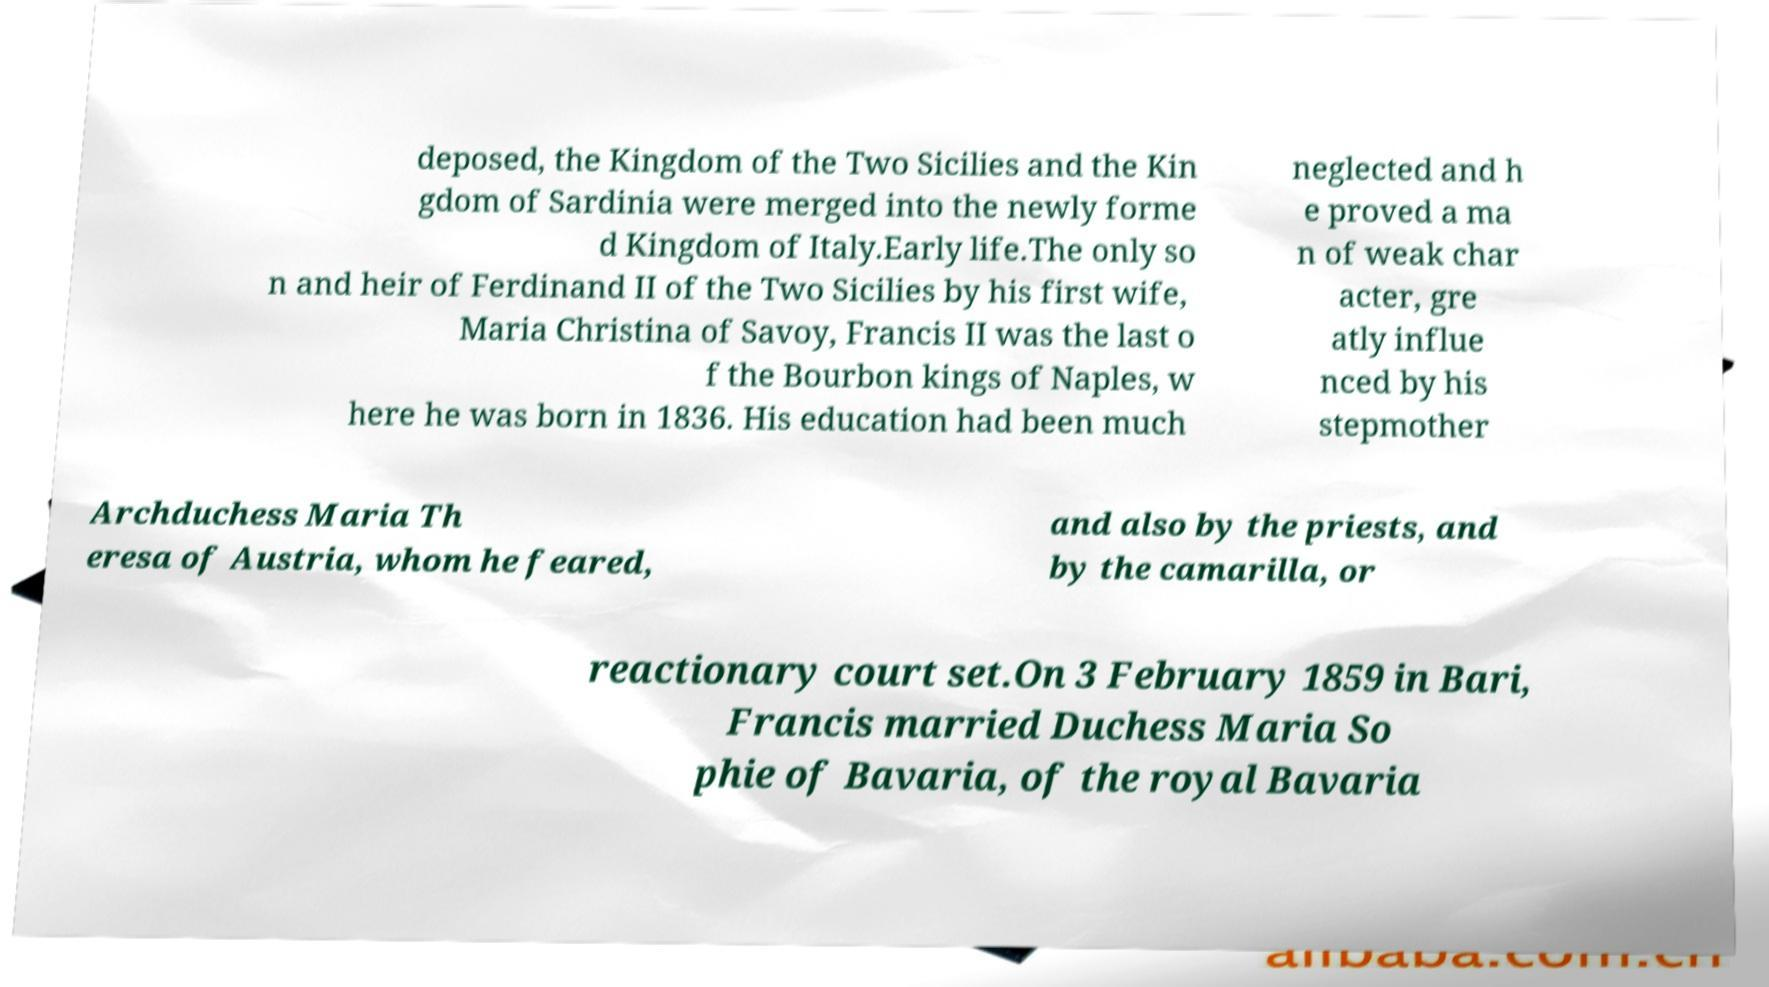What messages or text are displayed in this image? I need them in a readable, typed format. deposed, the Kingdom of the Two Sicilies and the Kin gdom of Sardinia were merged into the newly forme d Kingdom of Italy.Early life.The only so n and heir of Ferdinand II of the Two Sicilies by his first wife, Maria Christina of Savoy, Francis II was the last o f the Bourbon kings of Naples, w here he was born in 1836. His education had been much neglected and h e proved a ma n of weak char acter, gre atly influe nced by his stepmother Archduchess Maria Th eresa of Austria, whom he feared, and also by the priests, and by the camarilla, or reactionary court set.On 3 February 1859 in Bari, Francis married Duchess Maria So phie of Bavaria, of the royal Bavaria 